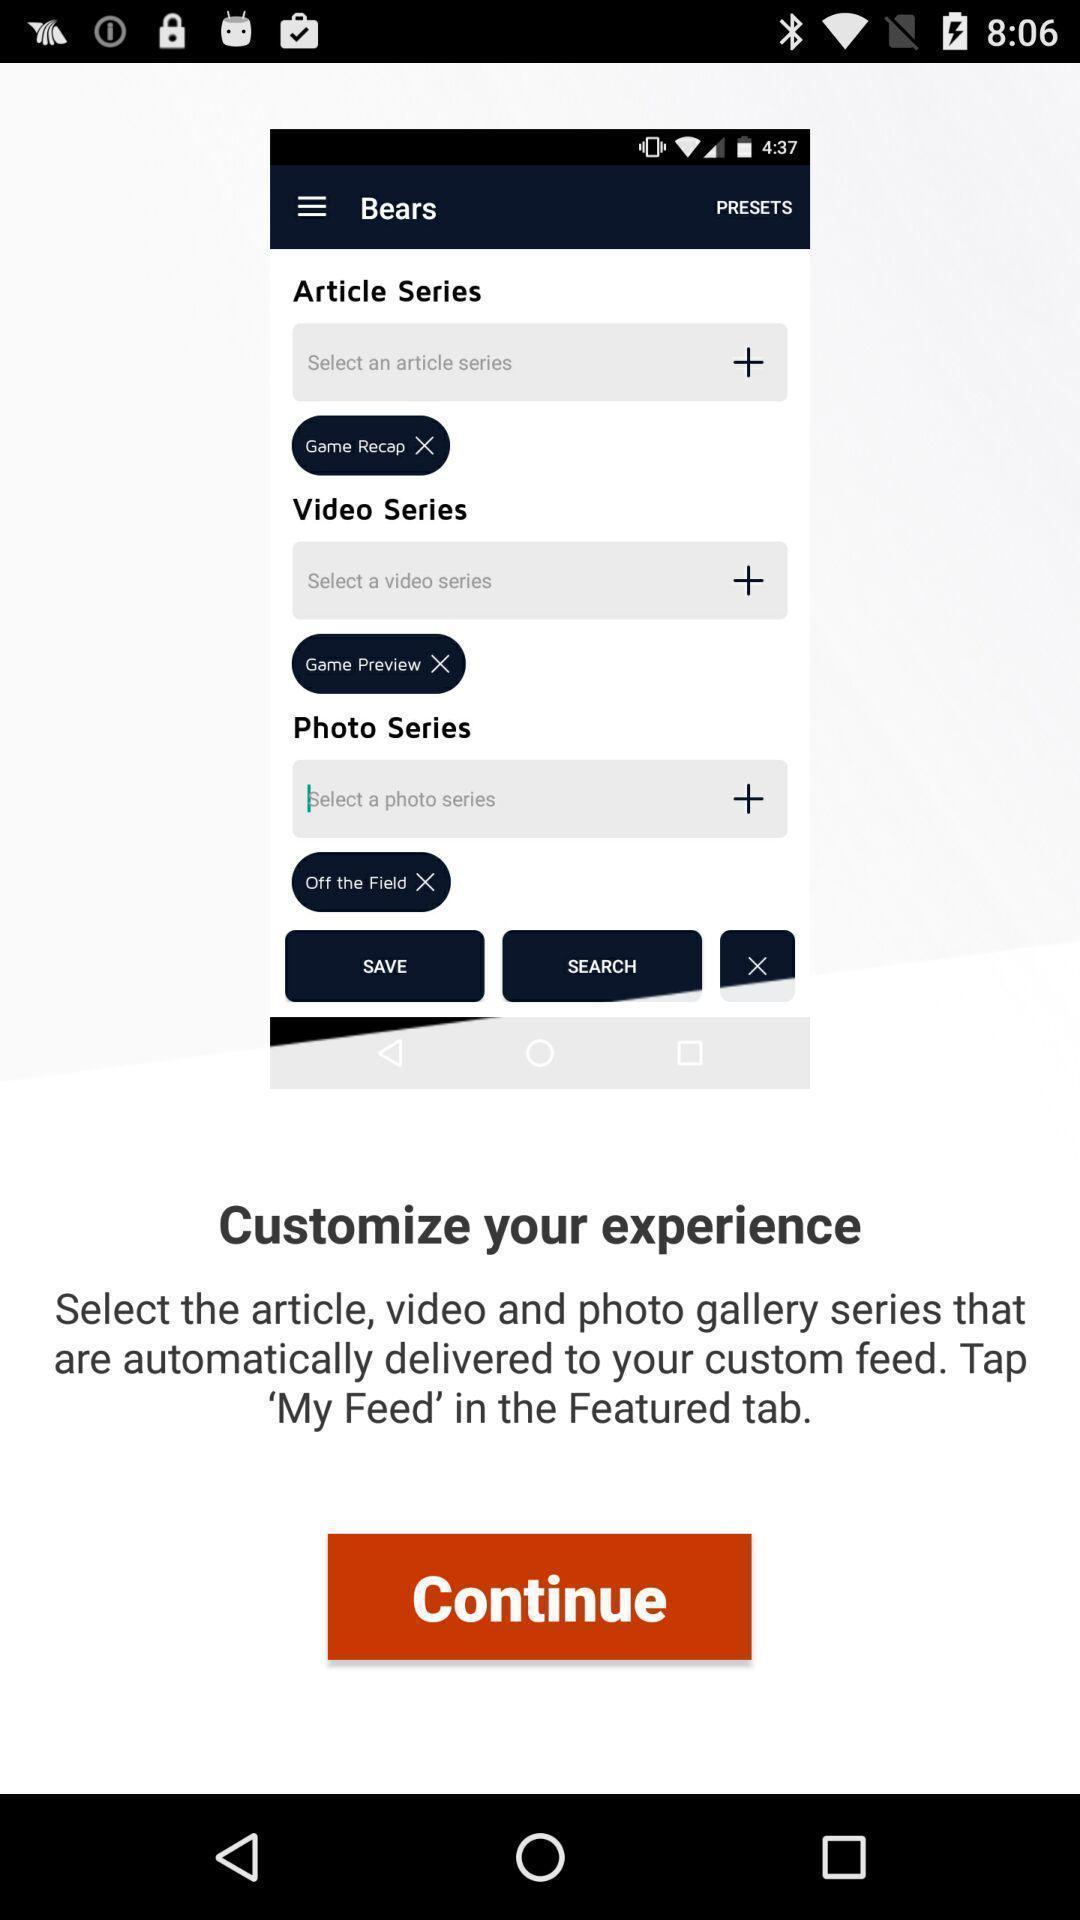Describe the visual elements of this screenshot. Page showing few information and continue button. 